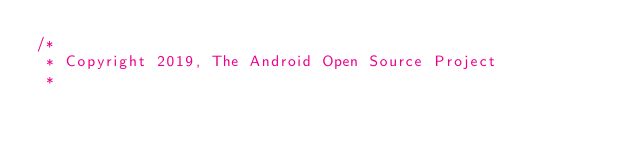<code> <loc_0><loc_0><loc_500><loc_500><_Kotlin_>/*
 * Copyright 2019, The Android Open Source Project
 *</code> 